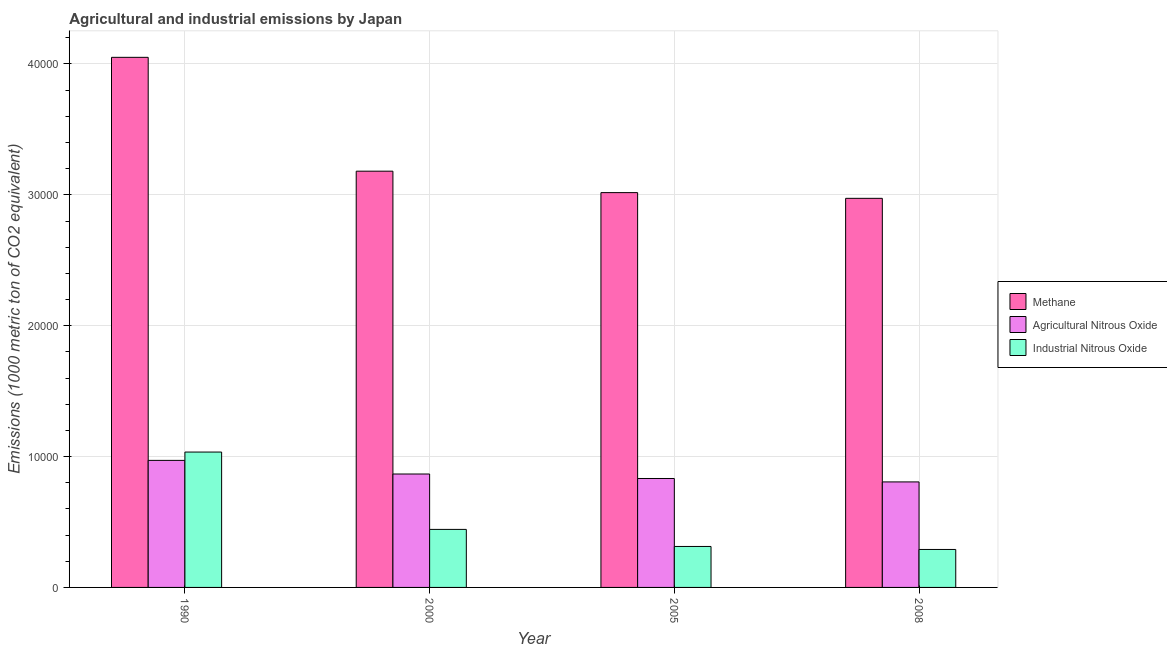How many different coloured bars are there?
Offer a terse response. 3. How many groups of bars are there?
Your response must be concise. 4. How many bars are there on the 2nd tick from the left?
Make the answer very short. 3. How many bars are there on the 1st tick from the right?
Provide a short and direct response. 3. What is the label of the 1st group of bars from the left?
Keep it short and to the point. 1990. In how many cases, is the number of bars for a given year not equal to the number of legend labels?
Offer a very short reply. 0. What is the amount of methane emissions in 1990?
Make the answer very short. 4.05e+04. Across all years, what is the maximum amount of agricultural nitrous oxide emissions?
Make the answer very short. 9708.8. Across all years, what is the minimum amount of agricultural nitrous oxide emissions?
Make the answer very short. 8063.7. In which year was the amount of agricultural nitrous oxide emissions maximum?
Your answer should be compact. 1990. In which year was the amount of methane emissions minimum?
Offer a very short reply. 2008. What is the total amount of agricultural nitrous oxide emissions in the graph?
Your answer should be compact. 3.48e+04. What is the difference between the amount of methane emissions in 1990 and that in 2000?
Keep it short and to the point. 8700.7. What is the difference between the amount of methane emissions in 2000 and the amount of agricultural nitrous oxide emissions in 2005?
Provide a succinct answer. 1638. What is the average amount of agricultural nitrous oxide emissions per year?
Give a very brief answer. 8691.1. What is the ratio of the amount of industrial nitrous oxide emissions in 1990 to that in 2005?
Your response must be concise. 3.3. Is the difference between the amount of industrial nitrous oxide emissions in 1990 and 2005 greater than the difference between the amount of methane emissions in 1990 and 2005?
Keep it short and to the point. No. What is the difference between the highest and the second highest amount of methane emissions?
Provide a succinct answer. 8700.7. What is the difference between the highest and the lowest amount of methane emissions?
Provide a succinct answer. 1.08e+04. In how many years, is the amount of methane emissions greater than the average amount of methane emissions taken over all years?
Ensure brevity in your answer.  1. What does the 2nd bar from the left in 2008 represents?
Keep it short and to the point. Agricultural Nitrous Oxide. What does the 3rd bar from the right in 2008 represents?
Ensure brevity in your answer.  Methane. How many bars are there?
Give a very brief answer. 12. Are all the bars in the graph horizontal?
Keep it short and to the point. No. What is the difference between two consecutive major ticks on the Y-axis?
Keep it short and to the point. 10000. Does the graph contain any zero values?
Provide a short and direct response. No. How many legend labels are there?
Make the answer very short. 3. What is the title of the graph?
Make the answer very short. Agricultural and industrial emissions by Japan. What is the label or title of the X-axis?
Your answer should be compact. Year. What is the label or title of the Y-axis?
Make the answer very short. Emissions (1000 metric ton of CO2 equivalent). What is the Emissions (1000 metric ton of CO2 equivalent) of Methane in 1990?
Provide a succinct answer. 4.05e+04. What is the Emissions (1000 metric ton of CO2 equivalent) in Agricultural Nitrous Oxide in 1990?
Offer a very short reply. 9708.8. What is the Emissions (1000 metric ton of CO2 equivalent) in Industrial Nitrous Oxide in 1990?
Offer a very short reply. 1.03e+04. What is the Emissions (1000 metric ton of CO2 equivalent) in Methane in 2000?
Give a very brief answer. 3.18e+04. What is the Emissions (1000 metric ton of CO2 equivalent) in Agricultural Nitrous Oxide in 2000?
Give a very brief answer. 8667.2. What is the Emissions (1000 metric ton of CO2 equivalent) of Industrial Nitrous Oxide in 2000?
Provide a succinct answer. 4433.9. What is the Emissions (1000 metric ton of CO2 equivalent) of Methane in 2005?
Offer a terse response. 3.02e+04. What is the Emissions (1000 metric ton of CO2 equivalent) of Agricultural Nitrous Oxide in 2005?
Provide a short and direct response. 8324.7. What is the Emissions (1000 metric ton of CO2 equivalent) of Industrial Nitrous Oxide in 2005?
Ensure brevity in your answer.  3130.3. What is the Emissions (1000 metric ton of CO2 equivalent) of Methane in 2008?
Provide a succinct answer. 2.97e+04. What is the Emissions (1000 metric ton of CO2 equivalent) in Agricultural Nitrous Oxide in 2008?
Provide a succinct answer. 8063.7. What is the Emissions (1000 metric ton of CO2 equivalent) in Industrial Nitrous Oxide in 2008?
Ensure brevity in your answer.  2901. Across all years, what is the maximum Emissions (1000 metric ton of CO2 equivalent) of Methane?
Keep it short and to the point. 4.05e+04. Across all years, what is the maximum Emissions (1000 metric ton of CO2 equivalent) in Agricultural Nitrous Oxide?
Your answer should be compact. 9708.8. Across all years, what is the maximum Emissions (1000 metric ton of CO2 equivalent) in Industrial Nitrous Oxide?
Provide a short and direct response. 1.03e+04. Across all years, what is the minimum Emissions (1000 metric ton of CO2 equivalent) in Methane?
Offer a terse response. 2.97e+04. Across all years, what is the minimum Emissions (1000 metric ton of CO2 equivalent) in Agricultural Nitrous Oxide?
Keep it short and to the point. 8063.7. Across all years, what is the minimum Emissions (1000 metric ton of CO2 equivalent) in Industrial Nitrous Oxide?
Your answer should be very brief. 2901. What is the total Emissions (1000 metric ton of CO2 equivalent) of Methane in the graph?
Your response must be concise. 1.32e+05. What is the total Emissions (1000 metric ton of CO2 equivalent) of Agricultural Nitrous Oxide in the graph?
Offer a terse response. 3.48e+04. What is the total Emissions (1000 metric ton of CO2 equivalent) in Industrial Nitrous Oxide in the graph?
Your response must be concise. 2.08e+04. What is the difference between the Emissions (1000 metric ton of CO2 equivalent) in Methane in 1990 and that in 2000?
Your answer should be very brief. 8700.7. What is the difference between the Emissions (1000 metric ton of CO2 equivalent) in Agricultural Nitrous Oxide in 1990 and that in 2000?
Keep it short and to the point. 1041.6. What is the difference between the Emissions (1000 metric ton of CO2 equivalent) in Industrial Nitrous Oxide in 1990 and that in 2000?
Offer a terse response. 5911.5. What is the difference between the Emissions (1000 metric ton of CO2 equivalent) of Methane in 1990 and that in 2005?
Offer a terse response. 1.03e+04. What is the difference between the Emissions (1000 metric ton of CO2 equivalent) in Agricultural Nitrous Oxide in 1990 and that in 2005?
Offer a very short reply. 1384.1. What is the difference between the Emissions (1000 metric ton of CO2 equivalent) of Industrial Nitrous Oxide in 1990 and that in 2005?
Provide a short and direct response. 7215.1. What is the difference between the Emissions (1000 metric ton of CO2 equivalent) in Methane in 1990 and that in 2008?
Provide a succinct answer. 1.08e+04. What is the difference between the Emissions (1000 metric ton of CO2 equivalent) in Agricultural Nitrous Oxide in 1990 and that in 2008?
Keep it short and to the point. 1645.1. What is the difference between the Emissions (1000 metric ton of CO2 equivalent) of Industrial Nitrous Oxide in 1990 and that in 2008?
Give a very brief answer. 7444.4. What is the difference between the Emissions (1000 metric ton of CO2 equivalent) of Methane in 2000 and that in 2005?
Provide a short and direct response. 1638. What is the difference between the Emissions (1000 metric ton of CO2 equivalent) in Agricultural Nitrous Oxide in 2000 and that in 2005?
Offer a terse response. 342.5. What is the difference between the Emissions (1000 metric ton of CO2 equivalent) in Industrial Nitrous Oxide in 2000 and that in 2005?
Keep it short and to the point. 1303.6. What is the difference between the Emissions (1000 metric ton of CO2 equivalent) of Methane in 2000 and that in 2008?
Ensure brevity in your answer.  2075.3. What is the difference between the Emissions (1000 metric ton of CO2 equivalent) in Agricultural Nitrous Oxide in 2000 and that in 2008?
Provide a succinct answer. 603.5. What is the difference between the Emissions (1000 metric ton of CO2 equivalent) of Industrial Nitrous Oxide in 2000 and that in 2008?
Make the answer very short. 1532.9. What is the difference between the Emissions (1000 metric ton of CO2 equivalent) in Methane in 2005 and that in 2008?
Give a very brief answer. 437.3. What is the difference between the Emissions (1000 metric ton of CO2 equivalent) of Agricultural Nitrous Oxide in 2005 and that in 2008?
Give a very brief answer. 261. What is the difference between the Emissions (1000 metric ton of CO2 equivalent) in Industrial Nitrous Oxide in 2005 and that in 2008?
Offer a very short reply. 229.3. What is the difference between the Emissions (1000 metric ton of CO2 equivalent) of Methane in 1990 and the Emissions (1000 metric ton of CO2 equivalent) of Agricultural Nitrous Oxide in 2000?
Ensure brevity in your answer.  3.18e+04. What is the difference between the Emissions (1000 metric ton of CO2 equivalent) of Methane in 1990 and the Emissions (1000 metric ton of CO2 equivalent) of Industrial Nitrous Oxide in 2000?
Your answer should be compact. 3.61e+04. What is the difference between the Emissions (1000 metric ton of CO2 equivalent) of Agricultural Nitrous Oxide in 1990 and the Emissions (1000 metric ton of CO2 equivalent) of Industrial Nitrous Oxide in 2000?
Your answer should be very brief. 5274.9. What is the difference between the Emissions (1000 metric ton of CO2 equivalent) of Methane in 1990 and the Emissions (1000 metric ton of CO2 equivalent) of Agricultural Nitrous Oxide in 2005?
Offer a terse response. 3.22e+04. What is the difference between the Emissions (1000 metric ton of CO2 equivalent) in Methane in 1990 and the Emissions (1000 metric ton of CO2 equivalent) in Industrial Nitrous Oxide in 2005?
Your response must be concise. 3.74e+04. What is the difference between the Emissions (1000 metric ton of CO2 equivalent) in Agricultural Nitrous Oxide in 1990 and the Emissions (1000 metric ton of CO2 equivalent) in Industrial Nitrous Oxide in 2005?
Make the answer very short. 6578.5. What is the difference between the Emissions (1000 metric ton of CO2 equivalent) of Methane in 1990 and the Emissions (1000 metric ton of CO2 equivalent) of Agricultural Nitrous Oxide in 2008?
Your response must be concise. 3.24e+04. What is the difference between the Emissions (1000 metric ton of CO2 equivalent) of Methane in 1990 and the Emissions (1000 metric ton of CO2 equivalent) of Industrial Nitrous Oxide in 2008?
Keep it short and to the point. 3.76e+04. What is the difference between the Emissions (1000 metric ton of CO2 equivalent) in Agricultural Nitrous Oxide in 1990 and the Emissions (1000 metric ton of CO2 equivalent) in Industrial Nitrous Oxide in 2008?
Give a very brief answer. 6807.8. What is the difference between the Emissions (1000 metric ton of CO2 equivalent) in Methane in 2000 and the Emissions (1000 metric ton of CO2 equivalent) in Agricultural Nitrous Oxide in 2005?
Ensure brevity in your answer.  2.35e+04. What is the difference between the Emissions (1000 metric ton of CO2 equivalent) of Methane in 2000 and the Emissions (1000 metric ton of CO2 equivalent) of Industrial Nitrous Oxide in 2005?
Your response must be concise. 2.87e+04. What is the difference between the Emissions (1000 metric ton of CO2 equivalent) in Agricultural Nitrous Oxide in 2000 and the Emissions (1000 metric ton of CO2 equivalent) in Industrial Nitrous Oxide in 2005?
Your response must be concise. 5536.9. What is the difference between the Emissions (1000 metric ton of CO2 equivalent) in Methane in 2000 and the Emissions (1000 metric ton of CO2 equivalent) in Agricultural Nitrous Oxide in 2008?
Keep it short and to the point. 2.37e+04. What is the difference between the Emissions (1000 metric ton of CO2 equivalent) in Methane in 2000 and the Emissions (1000 metric ton of CO2 equivalent) in Industrial Nitrous Oxide in 2008?
Provide a short and direct response. 2.89e+04. What is the difference between the Emissions (1000 metric ton of CO2 equivalent) in Agricultural Nitrous Oxide in 2000 and the Emissions (1000 metric ton of CO2 equivalent) in Industrial Nitrous Oxide in 2008?
Offer a terse response. 5766.2. What is the difference between the Emissions (1000 metric ton of CO2 equivalent) in Methane in 2005 and the Emissions (1000 metric ton of CO2 equivalent) in Agricultural Nitrous Oxide in 2008?
Make the answer very short. 2.21e+04. What is the difference between the Emissions (1000 metric ton of CO2 equivalent) in Methane in 2005 and the Emissions (1000 metric ton of CO2 equivalent) in Industrial Nitrous Oxide in 2008?
Provide a short and direct response. 2.73e+04. What is the difference between the Emissions (1000 metric ton of CO2 equivalent) in Agricultural Nitrous Oxide in 2005 and the Emissions (1000 metric ton of CO2 equivalent) in Industrial Nitrous Oxide in 2008?
Give a very brief answer. 5423.7. What is the average Emissions (1000 metric ton of CO2 equivalent) of Methane per year?
Your answer should be very brief. 3.31e+04. What is the average Emissions (1000 metric ton of CO2 equivalent) of Agricultural Nitrous Oxide per year?
Offer a very short reply. 8691.1. What is the average Emissions (1000 metric ton of CO2 equivalent) in Industrial Nitrous Oxide per year?
Your answer should be very brief. 5202.65. In the year 1990, what is the difference between the Emissions (1000 metric ton of CO2 equivalent) in Methane and Emissions (1000 metric ton of CO2 equivalent) in Agricultural Nitrous Oxide?
Offer a very short reply. 3.08e+04. In the year 1990, what is the difference between the Emissions (1000 metric ton of CO2 equivalent) of Methane and Emissions (1000 metric ton of CO2 equivalent) of Industrial Nitrous Oxide?
Provide a short and direct response. 3.02e+04. In the year 1990, what is the difference between the Emissions (1000 metric ton of CO2 equivalent) in Agricultural Nitrous Oxide and Emissions (1000 metric ton of CO2 equivalent) in Industrial Nitrous Oxide?
Your answer should be compact. -636.6. In the year 2000, what is the difference between the Emissions (1000 metric ton of CO2 equivalent) of Methane and Emissions (1000 metric ton of CO2 equivalent) of Agricultural Nitrous Oxide?
Offer a terse response. 2.31e+04. In the year 2000, what is the difference between the Emissions (1000 metric ton of CO2 equivalent) of Methane and Emissions (1000 metric ton of CO2 equivalent) of Industrial Nitrous Oxide?
Offer a terse response. 2.74e+04. In the year 2000, what is the difference between the Emissions (1000 metric ton of CO2 equivalent) in Agricultural Nitrous Oxide and Emissions (1000 metric ton of CO2 equivalent) in Industrial Nitrous Oxide?
Make the answer very short. 4233.3. In the year 2005, what is the difference between the Emissions (1000 metric ton of CO2 equivalent) of Methane and Emissions (1000 metric ton of CO2 equivalent) of Agricultural Nitrous Oxide?
Offer a terse response. 2.18e+04. In the year 2005, what is the difference between the Emissions (1000 metric ton of CO2 equivalent) in Methane and Emissions (1000 metric ton of CO2 equivalent) in Industrial Nitrous Oxide?
Provide a succinct answer. 2.70e+04. In the year 2005, what is the difference between the Emissions (1000 metric ton of CO2 equivalent) in Agricultural Nitrous Oxide and Emissions (1000 metric ton of CO2 equivalent) in Industrial Nitrous Oxide?
Give a very brief answer. 5194.4. In the year 2008, what is the difference between the Emissions (1000 metric ton of CO2 equivalent) of Methane and Emissions (1000 metric ton of CO2 equivalent) of Agricultural Nitrous Oxide?
Ensure brevity in your answer.  2.17e+04. In the year 2008, what is the difference between the Emissions (1000 metric ton of CO2 equivalent) of Methane and Emissions (1000 metric ton of CO2 equivalent) of Industrial Nitrous Oxide?
Your response must be concise. 2.68e+04. In the year 2008, what is the difference between the Emissions (1000 metric ton of CO2 equivalent) in Agricultural Nitrous Oxide and Emissions (1000 metric ton of CO2 equivalent) in Industrial Nitrous Oxide?
Your response must be concise. 5162.7. What is the ratio of the Emissions (1000 metric ton of CO2 equivalent) in Methane in 1990 to that in 2000?
Your answer should be very brief. 1.27. What is the ratio of the Emissions (1000 metric ton of CO2 equivalent) of Agricultural Nitrous Oxide in 1990 to that in 2000?
Your response must be concise. 1.12. What is the ratio of the Emissions (1000 metric ton of CO2 equivalent) in Industrial Nitrous Oxide in 1990 to that in 2000?
Your response must be concise. 2.33. What is the ratio of the Emissions (1000 metric ton of CO2 equivalent) in Methane in 1990 to that in 2005?
Offer a terse response. 1.34. What is the ratio of the Emissions (1000 metric ton of CO2 equivalent) in Agricultural Nitrous Oxide in 1990 to that in 2005?
Keep it short and to the point. 1.17. What is the ratio of the Emissions (1000 metric ton of CO2 equivalent) of Industrial Nitrous Oxide in 1990 to that in 2005?
Offer a very short reply. 3.3. What is the ratio of the Emissions (1000 metric ton of CO2 equivalent) of Methane in 1990 to that in 2008?
Give a very brief answer. 1.36. What is the ratio of the Emissions (1000 metric ton of CO2 equivalent) of Agricultural Nitrous Oxide in 1990 to that in 2008?
Provide a succinct answer. 1.2. What is the ratio of the Emissions (1000 metric ton of CO2 equivalent) in Industrial Nitrous Oxide in 1990 to that in 2008?
Offer a very short reply. 3.57. What is the ratio of the Emissions (1000 metric ton of CO2 equivalent) in Methane in 2000 to that in 2005?
Your answer should be compact. 1.05. What is the ratio of the Emissions (1000 metric ton of CO2 equivalent) in Agricultural Nitrous Oxide in 2000 to that in 2005?
Offer a very short reply. 1.04. What is the ratio of the Emissions (1000 metric ton of CO2 equivalent) in Industrial Nitrous Oxide in 2000 to that in 2005?
Ensure brevity in your answer.  1.42. What is the ratio of the Emissions (1000 metric ton of CO2 equivalent) in Methane in 2000 to that in 2008?
Give a very brief answer. 1.07. What is the ratio of the Emissions (1000 metric ton of CO2 equivalent) in Agricultural Nitrous Oxide in 2000 to that in 2008?
Your answer should be compact. 1.07. What is the ratio of the Emissions (1000 metric ton of CO2 equivalent) in Industrial Nitrous Oxide in 2000 to that in 2008?
Ensure brevity in your answer.  1.53. What is the ratio of the Emissions (1000 metric ton of CO2 equivalent) in Methane in 2005 to that in 2008?
Ensure brevity in your answer.  1.01. What is the ratio of the Emissions (1000 metric ton of CO2 equivalent) in Agricultural Nitrous Oxide in 2005 to that in 2008?
Keep it short and to the point. 1.03. What is the ratio of the Emissions (1000 metric ton of CO2 equivalent) in Industrial Nitrous Oxide in 2005 to that in 2008?
Your response must be concise. 1.08. What is the difference between the highest and the second highest Emissions (1000 metric ton of CO2 equivalent) of Methane?
Provide a short and direct response. 8700.7. What is the difference between the highest and the second highest Emissions (1000 metric ton of CO2 equivalent) of Agricultural Nitrous Oxide?
Give a very brief answer. 1041.6. What is the difference between the highest and the second highest Emissions (1000 metric ton of CO2 equivalent) in Industrial Nitrous Oxide?
Your answer should be compact. 5911.5. What is the difference between the highest and the lowest Emissions (1000 metric ton of CO2 equivalent) of Methane?
Your response must be concise. 1.08e+04. What is the difference between the highest and the lowest Emissions (1000 metric ton of CO2 equivalent) of Agricultural Nitrous Oxide?
Keep it short and to the point. 1645.1. What is the difference between the highest and the lowest Emissions (1000 metric ton of CO2 equivalent) of Industrial Nitrous Oxide?
Your response must be concise. 7444.4. 